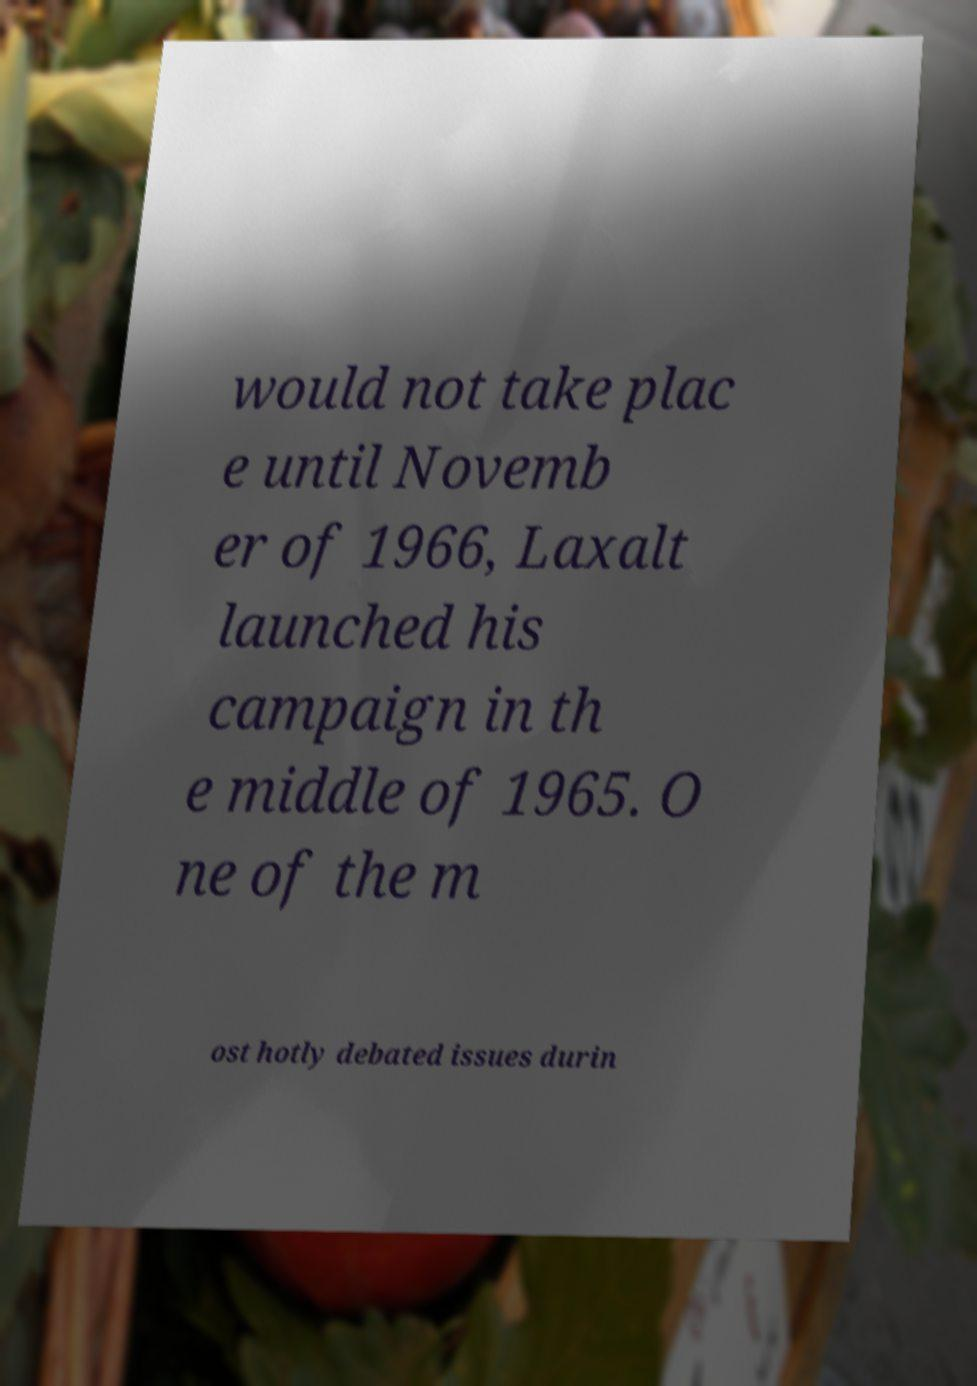Could you assist in decoding the text presented in this image and type it out clearly? would not take plac e until Novemb er of 1966, Laxalt launched his campaign in th e middle of 1965. O ne of the m ost hotly debated issues durin 